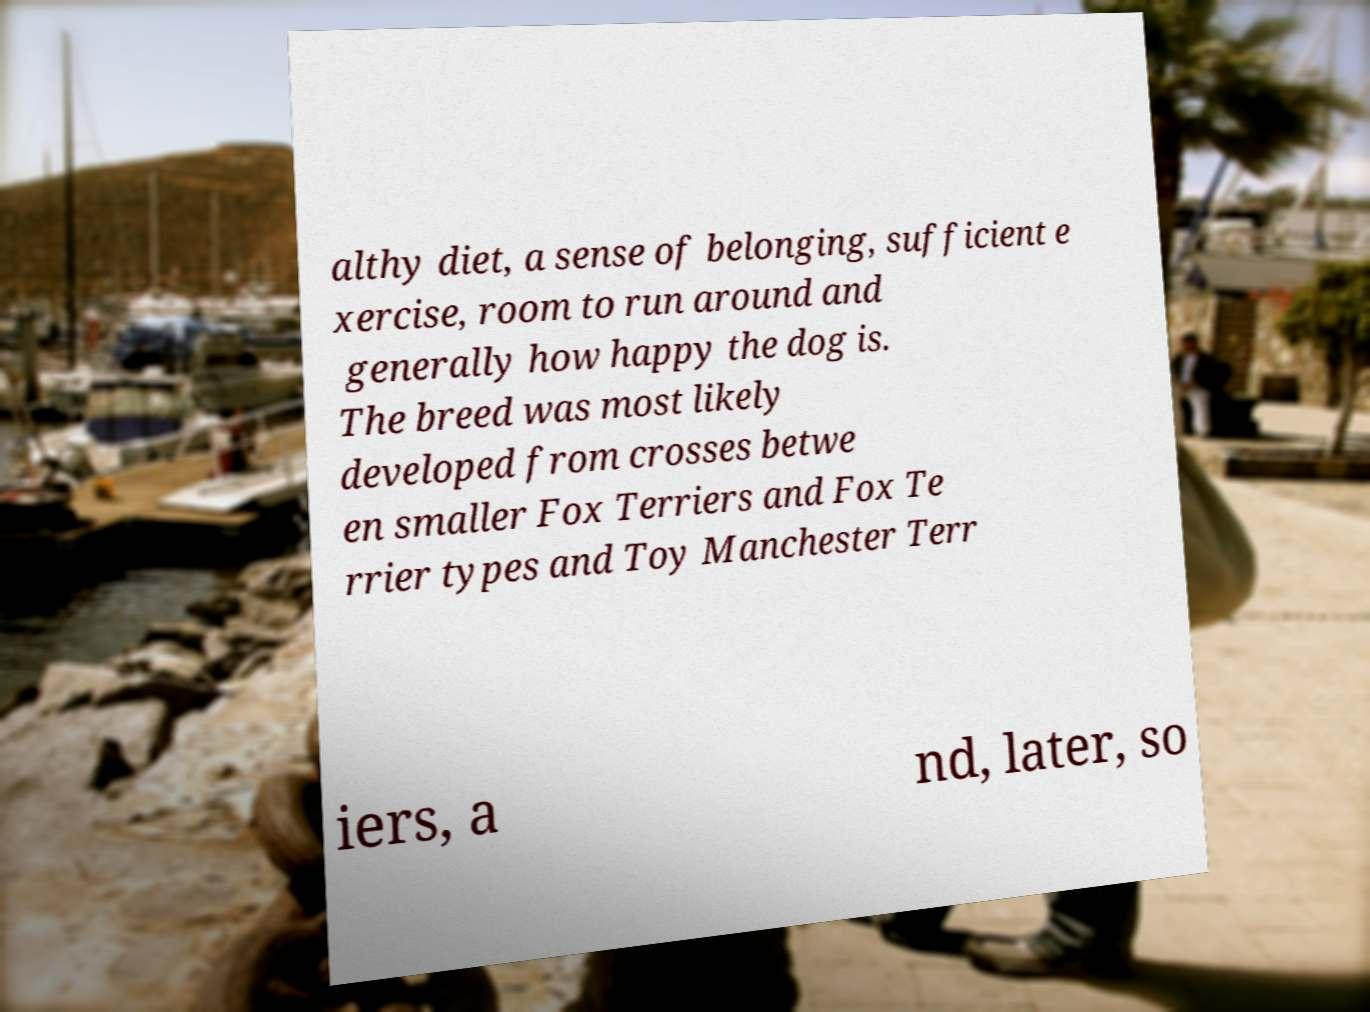Please read and relay the text visible in this image. What does it say? althy diet, a sense of belonging, sufficient e xercise, room to run around and generally how happy the dog is. The breed was most likely developed from crosses betwe en smaller Fox Terriers and Fox Te rrier types and Toy Manchester Terr iers, a nd, later, so 